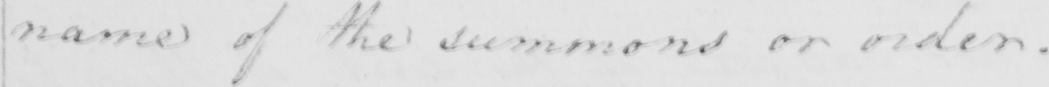Can you tell me what this handwritten text says? name of the summons or order . 